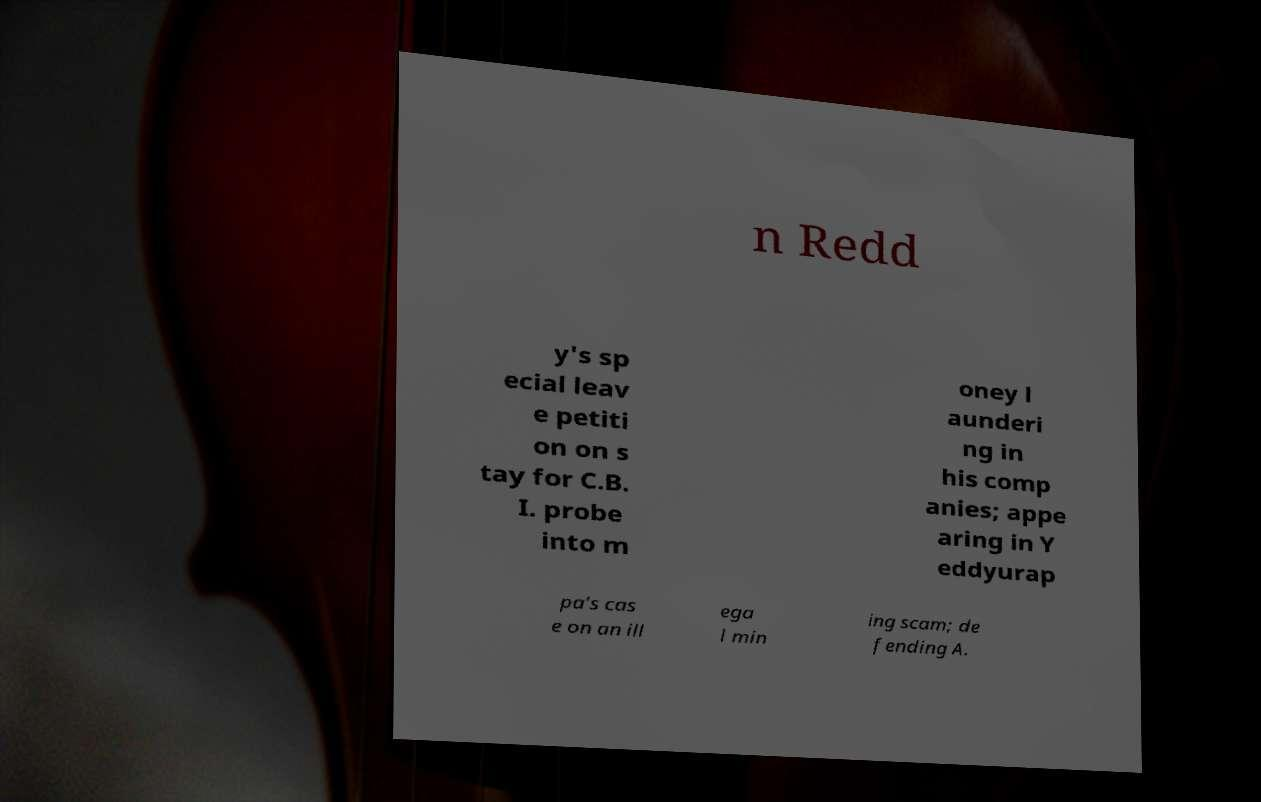Please read and relay the text visible in this image. What does it say? n Redd y's sp ecial leav e petiti on on s tay for C.B. I. probe into m oney l aunderi ng in his comp anies; appe aring in Y eddyurap pa's cas e on an ill ega l min ing scam; de fending A. 